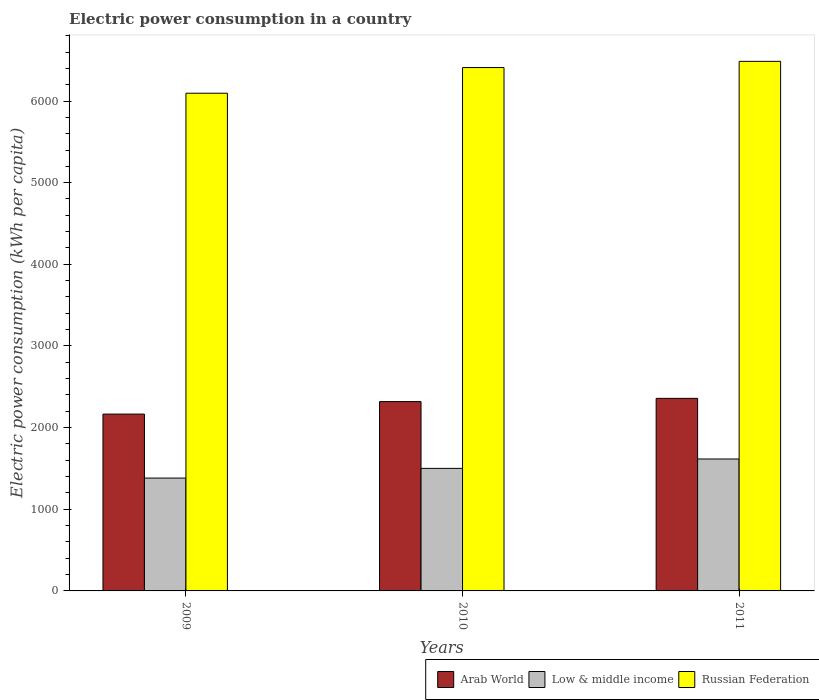How many groups of bars are there?
Keep it short and to the point. 3. Are the number of bars per tick equal to the number of legend labels?
Your answer should be very brief. Yes. Are the number of bars on each tick of the X-axis equal?
Ensure brevity in your answer.  Yes. How many bars are there on the 2nd tick from the left?
Offer a very short reply. 3. What is the label of the 3rd group of bars from the left?
Make the answer very short. 2011. What is the electric power consumption in in Low & middle income in 2011?
Your response must be concise. 1615.81. Across all years, what is the maximum electric power consumption in in Arab World?
Your response must be concise. 2358.48. Across all years, what is the minimum electric power consumption in in Arab World?
Offer a very short reply. 2165.73. In which year was the electric power consumption in in Russian Federation maximum?
Provide a succinct answer. 2011. What is the total electric power consumption in in Low & middle income in the graph?
Give a very brief answer. 4498.72. What is the difference between the electric power consumption in in Low & middle income in 2009 and that in 2011?
Provide a short and direct response. -233.74. What is the difference between the electric power consumption in in Arab World in 2011 and the electric power consumption in in Low & middle income in 2010?
Keep it short and to the point. 857.66. What is the average electric power consumption in in Arab World per year?
Make the answer very short. 2280.97. In the year 2011, what is the difference between the electric power consumption in in Arab World and electric power consumption in in Low & middle income?
Offer a terse response. 742.67. What is the ratio of the electric power consumption in in Low & middle income in 2009 to that in 2010?
Offer a terse response. 0.92. Is the electric power consumption in in Low & middle income in 2009 less than that in 2010?
Offer a very short reply. Yes. Is the difference between the electric power consumption in in Arab World in 2010 and 2011 greater than the difference between the electric power consumption in in Low & middle income in 2010 and 2011?
Keep it short and to the point. Yes. What is the difference between the highest and the second highest electric power consumption in in Russian Federation?
Keep it short and to the point. 75.87. What is the difference between the highest and the lowest electric power consumption in in Low & middle income?
Make the answer very short. 233.74. In how many years, is the electric power consumption in in Russian Federation greater than the average electric power consumption in in Russian Federation taken over all years?
Offer a terse response. 2. What does the 2nd bar from the left in 2009 represents?
Your answer should be compact. Low & middle income. What does the 3rd bar from the right in 2010 represents?
Make the answer very short. Arab World. Are all the bars in the graph horizontal?
Your answer should be compact. No. What is the difference between two consecutive major ticks on the Y-axis?
Keep it short and to the point. 1000. Are the values on the major ticks of Y-axis written in scientific E-notation?
Offer a very short reply. No. Does the graph contain any zero values?
Offer a terse response. No. Where does the legend appear in the graph?
Offer a terse response. Bottom right. How are the legend labels stacked?
Ensure brevity in your answer.  Horizontal. What is the title of the graph?
Keep it short and to the point. Electric power consumption in a country. Does "Nepal" appear as one of the legend labels in the graph?
Your answer should be very brief. No. What is the label or title of the Y-axis?
Provide a short and direct response. Electric power consumption (kWh per capita). What is the Electric power consumption (kWh per capita) in Arab World in 2009?
Give a very brief answer. 2165.73. What is the Electric power consumption (kWh per capita) in Low & middle income in 2009?
Your answer should be compact. 1382.08. What is the Electric power consumption (kWh per capita) in Russian Federation in 2009?
Your answer should be very brief. 6095.38. What is the Electric power consumption (kWh per capita) in Arab World in 2010?
Ensure brevity in your answer.  2318.68. What is the Electric power consumption (kWh per capita) of Low & middle income in 2010?
Provide a short and direct response. 1500.82. What is the Electric power consumption (kWh per capita) of Russian Federation in 2010?
Provide a short and direct response. 6409.9. What is the Electric power consumption (kWh per capita) in Arab World in 2011?
Ensure brevity in your answer.  2358.48. What is the Electric power consumption (kWh per capita) in Low & middle income in 2011?
Give a very brief answer. 1615.81. What is the Electric power consumption (kWh per capita) of Russian Federation in 2011?
Your response must be concise. 6485.76. Across all years, what is the maximum Electric power consumption (kWh per capita) in Arab World?
Your answer should be very brief. 2358.48. Across all years, what is the maximum Electric power consumption (kWh per capita) of Low & middle income?
Offer a very short reply. 1615.81. Across all years, what is the maximum Electric power consumption (kWh per capita) in Russian Federation?
Keep it short and to the point. 6485.76. Across all years, what is the minimum Electric power consumption (kWh per capita) in Arab World?
Make the answer very short. 2165.73. Across all years, what is the minimum Electric power consumption (kWh per capita) in Low & middle income?
Keep it short and to the point. 1382.08. Across all years, what is the minimum Electric power consumption (kWh per capita) of Russian Federation?
Ensure brevity in your answer.  6095.38. What is the total Electric power consumption (kWh per capita) of Arab World in the graph?
Your answer should be compact. 6842.9. What is the total Electric power consumption (kWh per capita) in Low & middle income in the graph?
Make the answer very short. 4498.72. What is the total Electric power consumption (kWh per capita) of Russian Federation in the graph?
Give a very brief answer. 1.90e+04. What is the difference between the Electric power consumption (kWh per capita) of Arab World in 2009 and that in 2010?
Provide a succinct answer. -152.94. What is the difference between the Electric power consumption (kWh per capita) in Low & middle income in 2009 and that in 2010?
Offer a very short reply. -118.75. What is the difference between the Electric power consumption (kWh per capita) of Russian Federation in 2009 and that in 2010?
Your answer should be very brief. -314.51. What is the difference between the Electric power consumption (kWh per capita) in Arab World in 2009 and that in 2011?
Offer a terse response. -192.75. What is the difference between the Electric power consumption (kWh per capita) in Low & middle income in 2009 and that in 2011?
Your response must be concise. -233.74. What is the difference between the Electric power consumption (kWh per capita) of Russian Federation in 2009 and that in 2011?
Your answer should be very brief. -390.38. What is the difference between the Electric power consumption (kWh per capita) of Arab World in 2010 and that in 2011?
Keep it short and to the point. -39.8. What is the difference between the Electric power consumption (kWh per capita) in Low & middle income in 2010 and that in 2011?
Your answer should be compact. -114.99. What is the difference between the Electric power consumption (kWh per capita) in Russian Federation in 2010 and that in 2011?
Your response must be concise. -75.87. What is the difference between the Electric power consumption (kWh per capita) in Arab World in 2009 and the Electric power consumption (kWh per capita) in Low & middle income in 2010?
Offer a terse response. 664.91. What is the difference between the Electric power consumption (kWh per capita) in Arab World in 2009 and the Electric power consumption (kWh per capita) in Russian Federation in 2010?
Provide a succinct answer. -4244.16. What is the difference between the Electric power consumption (kWh per capita) of Low & middle income in 2009 and the Electric power consumption (kWh per capita) of Russian Federation in 2010?
Keep it short and to the point. -5027.82. What is the difference between the Electric power consumption (kWh per capita) in Arab World in 2009 and the Electric power consumption (kWh per capita) in Low & middle income in 2011?
Make the answer very short. 549.92. What is the difference between the Electric power consumption (kWh per capita) of Arab World in 2009 and the Electric power consumption (kWh per capita) of Russian Federation in 2011?
Offer a very short reply. -4320.03. What is the difference between the Electric power consumption (kWh per capita) in Low & middle income in 2009 and the Electric power consumption (kWh per capita) in Russian Federation in 2011?
Ensure brevity in your answer.  -5103.68. What is the difference between the Electric power consumption (kWh per capita) of Arab World in 2010 and the Electric power consumption (kWh per capita) of Low & middle income in 2011?
Give a very brief answer. 702.87. What is the difference between the Electric power consumption (kWh per capita) of Arab World in 2010 and the Electric power consumption (kWh per capita) of Russian Federation in 2011?
Make the answer very short. -4167.08. What is the difference between the Electric power consumption (kWh per capita) of Low & middle income in 2010 and the Electric power consumption (kWh per capita) of Russian Federation in 2011?
Give a very brief answer. -4984.94. What is the average Electric power consumption (kWh per capita) in Arab World per year?
Provide a short and direct response. 2280.97. What is the average Electric power consumption (kWh per capita) of Low & middle income per year?
Keep it short and to the point. 1499.57. What is the average Electric power consumption (kWh per capita) in Russian Federation per year?
Ensure brevity in your answer.  6330.35. In the year 2009, what is the difference between the Electric power consumption (kWh per capita) of Arab World and Electric power consumption (kWh per capita) of Low & middle income?
Offer a terse response. 783.66. In the year 2009, what is the difference between the Electric power consumption (kWh per capita) in Arab World and Electric power consumption (kWh per capita) in Russian Federation?
Offer a terse response. -3929.65. In the year 2009, what is the difference between the Electric power consumption (kWh per capita) in Low & middle income and Electric power consumption (kWh per capita) in Russian Federation?
Your answer should be compact. -4713.3. In the year 2010, what is the difference between the Electric power consumption (kWh per capita) of Arab World and Electric power consumption (kWh per capita) of Low & middle income?
Make the answer very short. 817.85. In the year 2010, what is the difference between the Electric power consumption (kWh per capita) of Arab World and Electric power consumption (kWh per capita) of Russian Federation?
Your answer should be compact. -4091.22. In the year 2010, what is the difference between the Electric power consumption (kWh per capita) of Low & middle income and Electric power consumption (kWh per capita) of Russian Federation?
Make the answer very short. -4909.07. In the year 2011, what is the difference between the Electric power consumption (kWh per capita) of Arab World and Electric power consumption (kWh per capita) of Low & middle income?
Your answer should be very brief. 742.67. In the year 2011, what is the difference between the Electric power consumption (kWh per capita) of Arab World and Electric power consumption (kWh per capita) of Russian Federation?
Your answer should be compact. -4127.28. In the year 2011, what is the difference between the Electric power consumption (kWh per capita) in Low & middle income and Electric power consumption (kWh per capita) in Russian Federation?
Provide a short and direct response. -4869.95. What is the ratio of the Electric power consumption (kWh per capita) of Arab World in 2009 to that in 2010?
Keep it short and to the point. 0.93. What is the ratio of the Electric power consumption (kWh per capita) of Low & middle income in 2009 to that in 2010?
Your answer should be very brief. 0.92. What is the ratio of the Electric power consumption (kWh per capita) of Russian Federation in 2009 to that in 2010?
Give a very brief answer. 0.95. What is the ratio of the Electric power consumption (kWh per capita) of Arab World in 2009 to that in 2011?
Offer a very short reply. 0.92. What is the ratio of the Electric power consumption (kWh per capita) of Low & middle income in 2009 to that in 2011?
Provide a short and direct response. 0.86. What is the ratio of the Electric power consumption (kWh per capita) of Russian Federation in 2009 to that in 2011?
Your answer should be very brief. 0.94. What is the ratio of the Electric power consumption (kWh per capita) in Arab World in 2010 to that in 2011?
Your answer should be compact. 0.98. What is the ratio of the Electric power consumption (kWh per capita) of Low & middle income in 2010 to that in 2011?
Provide a succinct answer. 0.93. What is the ratio of the Electric power consumption (kWh per capita) in Russian Federation in 2010 to that in 2011?
Make the answer very short. 0.99. What is the difference between the highest and the second highest Electric power consumption (kWh per capita) in Arab World?
Ensure brevity in your answer.  39.8. What is the difference between the highest and the second highest Electric power consumption (kWh per capita) in Low & middle income?
Offer a very short reply. 114.99. What is the difference between the highest and the second highest Electric power consumption (kWh per capita) in Russian Federation?
Give a very brief answer. 75.87. What is the difference between the highest and the lowest Electric power consumption (kWh per capita) in Arab World?
Your response must be concise. 192.75. What is the difference between the highest and the lowest Electric power consumption (kWh per capita) in Low & middle income?
Your response must be concise. 233.74. What is the difference between the highest and the lowest Electric power consumption (kWh per capita) of Russian Federation?
Give a very brief answer. 390.38. 